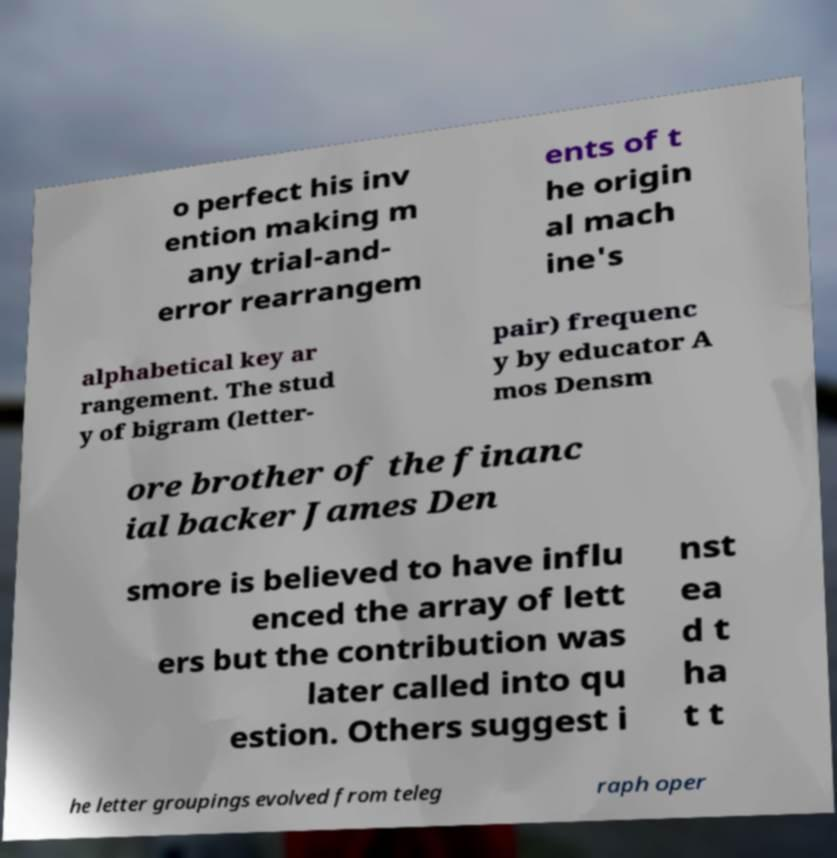Can you read and provide the text displayed in the image?This photo seems to have some interesting text. Can you extract and type it out for me? o perfect his inv ention making m any trial-and- error rearrangem ents of t he origin al mach ine's alphabetical key ar rangement. The stud y of bigram (letter- pair) frequenc y by educator A mos Densm ore brother of the financ ial backer James Den smore is believed to have influ enced the array of lett ers but the contribution was later called into qu estion. Others suggest i nst ea d t ha t t he letter groupings evolved from teleg raph oper 